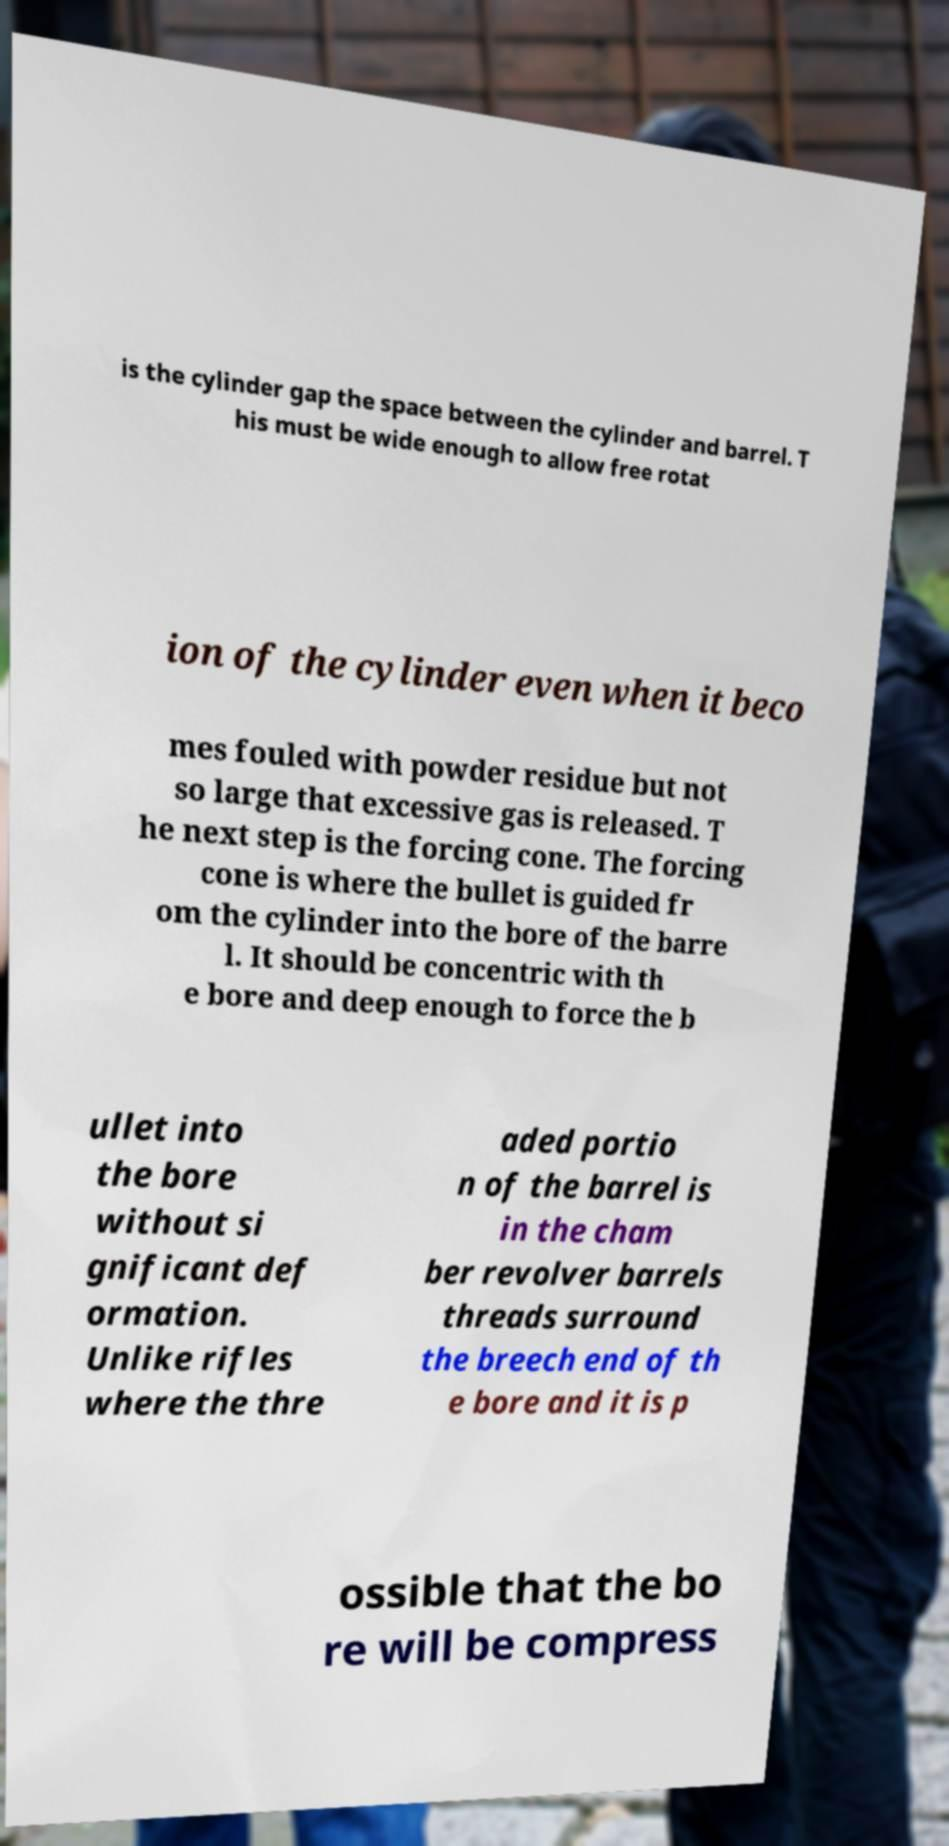Please read and relay the text visible in this image. What does it say? is the cylinder gap the space between the cylinder and barrel. T his must be wide enough to allow free rotat ion of the cylinder even when it beco mes fouled with powder residue but not so large that excessive gas is released. T he next step is the forcing cone. The forcing cone is where the bullet is guided fr om the cylinder into the bore of the barre l. It should be concentric with th e bore and deep enough to force the b ullet into the bore without si gnificant def ormation. Unlike rifles where the thre aded portio n of the barrel is in the cham ber revolver barrels threads surround the breech end of th e bore and it is p ossible that the bo re will be compress 